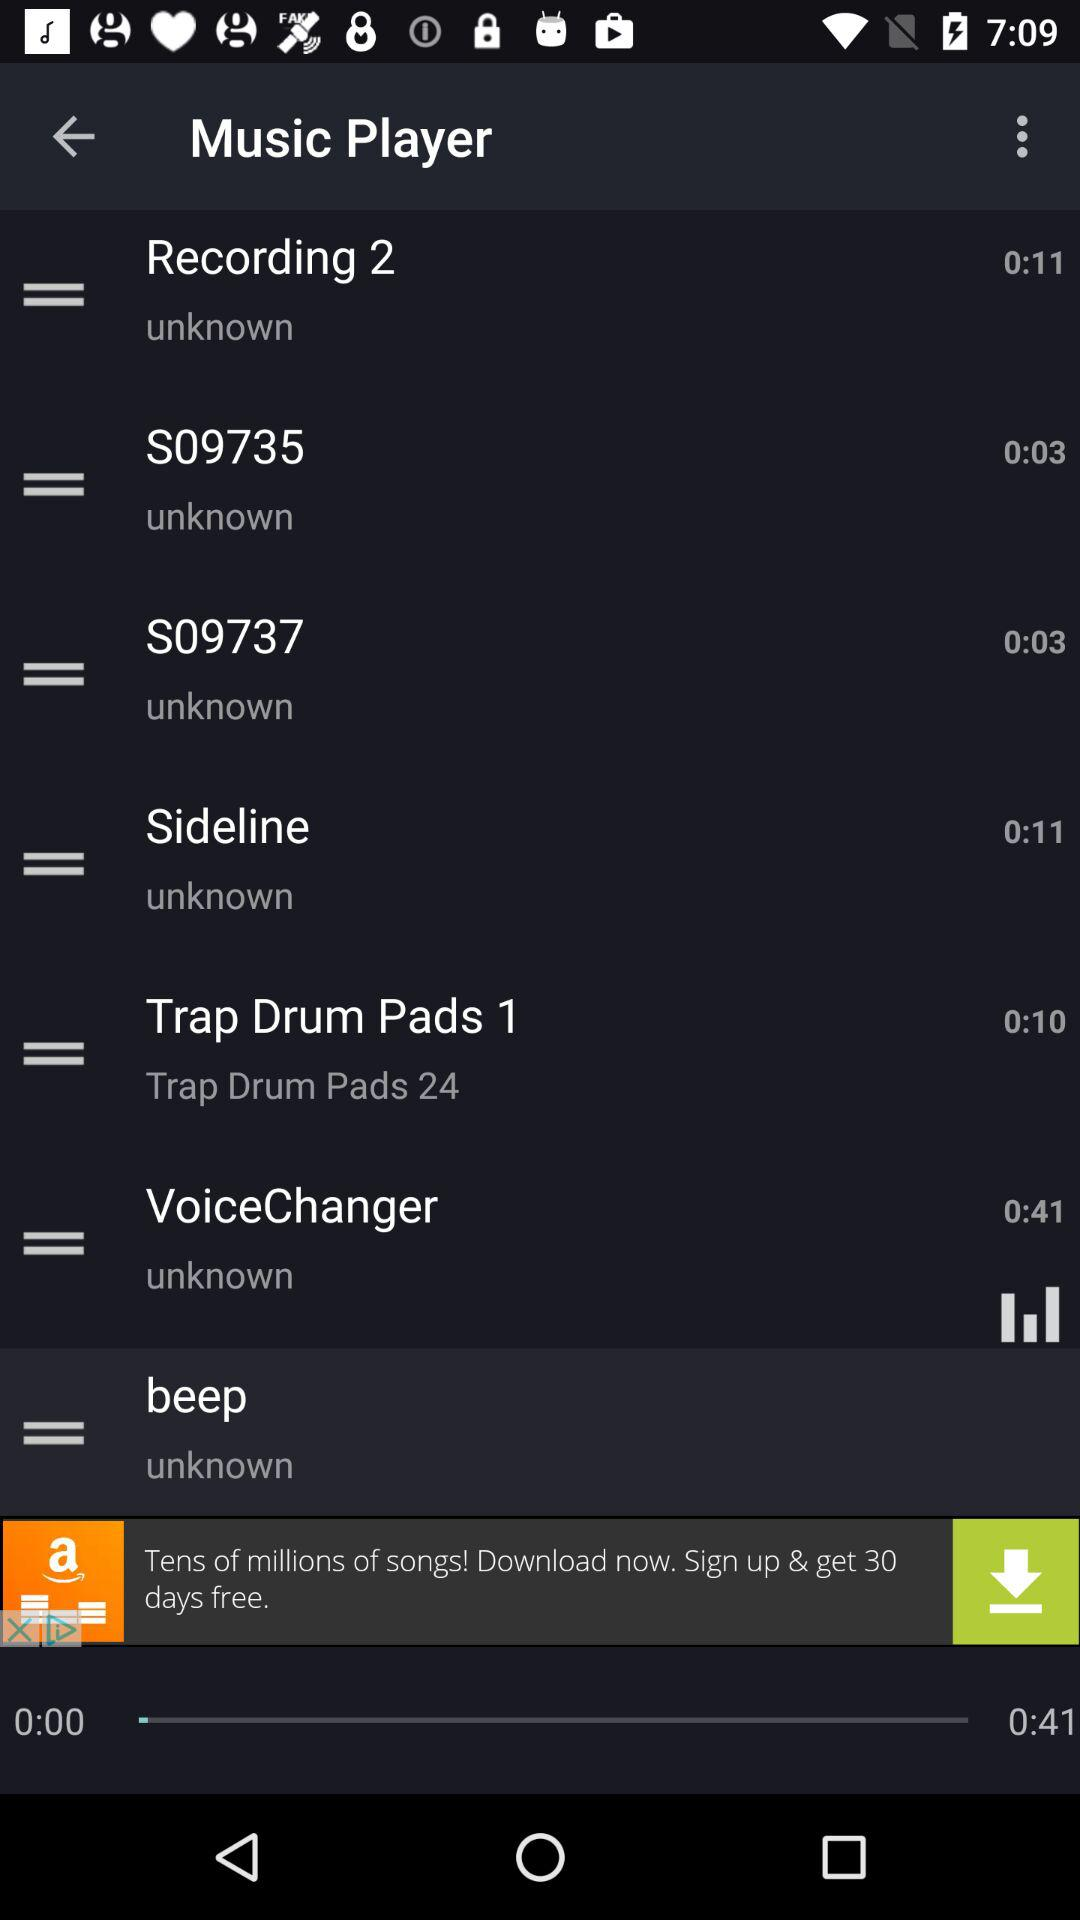What is the duration of the "VoiceChanger" audio? The duration is 41 seconds. 